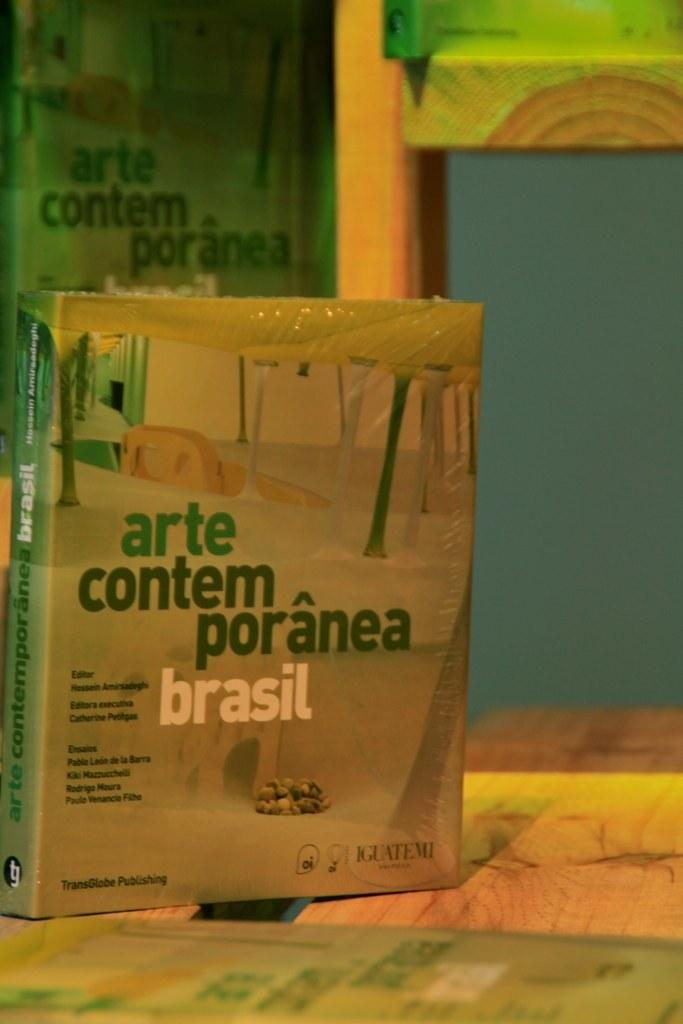<image>
Offer a succinct explanation of the picture presented. A brown and green book titled Arte Contemporanea Brasil. 